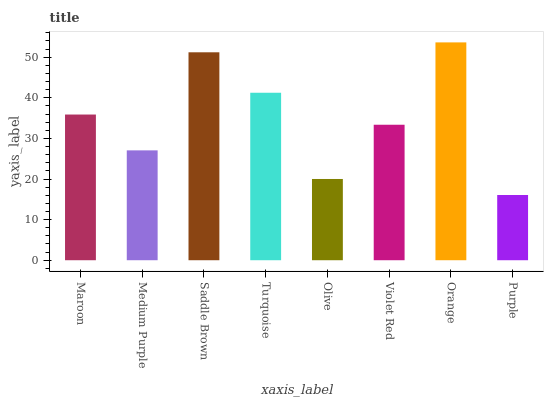Is Purple the minimum?
Answer yes or no. Yes. Is Orange the maximum?
Answer yes or no. Yes. Is Medium Purple the minimum?
Answer yes or no. No. Is Medium Purple the maximum?
Answer yes or no. No. Is Maroon greater than Medium Purple?
Answer yes or no. Yes. Is Medium Purple less than Maroon?
Answer yes or no. Yes. Is Medium Purple greater than Maroon?
Answer yes or no. No. Is Maroon less than Medium Purple?
Answer yes or no. No. Is Maroon the high median?
Answer yes or no. Yes. Is Violet Red the low median?
Answer yes or no. Yes. Is Medium Purple the high median?
Answer yes or no. No. Is Saddle Brown the low median?
Answer yes or no. No. 